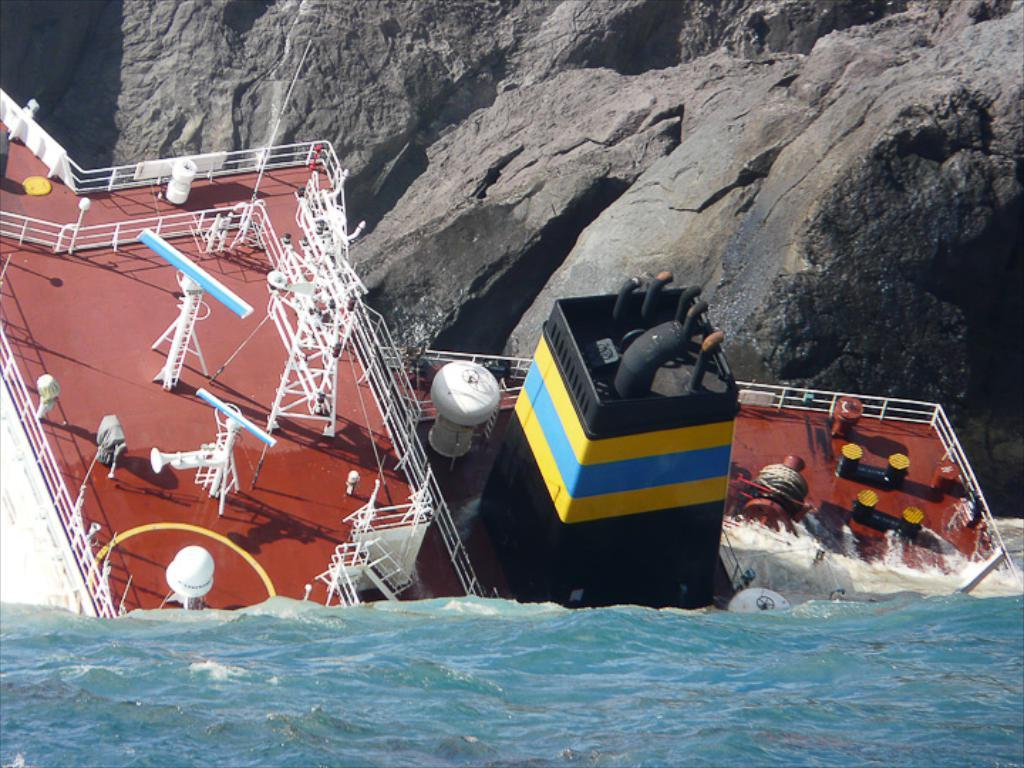What is in the foreground of the image? There is water in the foreground of the image. What can be seen in the water? There is a ship in the image. What is the condition of the ship? The ship appears to be drowning. What is located at the top of the image? There is a rock at the top of the image. How would you describe the weather in the image? It is a sunny day. What type of cloth is draped over the ship's mast in the image? There is no cloth present on the ship's mast in the image. How many books can be seen on the rock at the top of the image? There are no books present on the rock at the top of the image. 